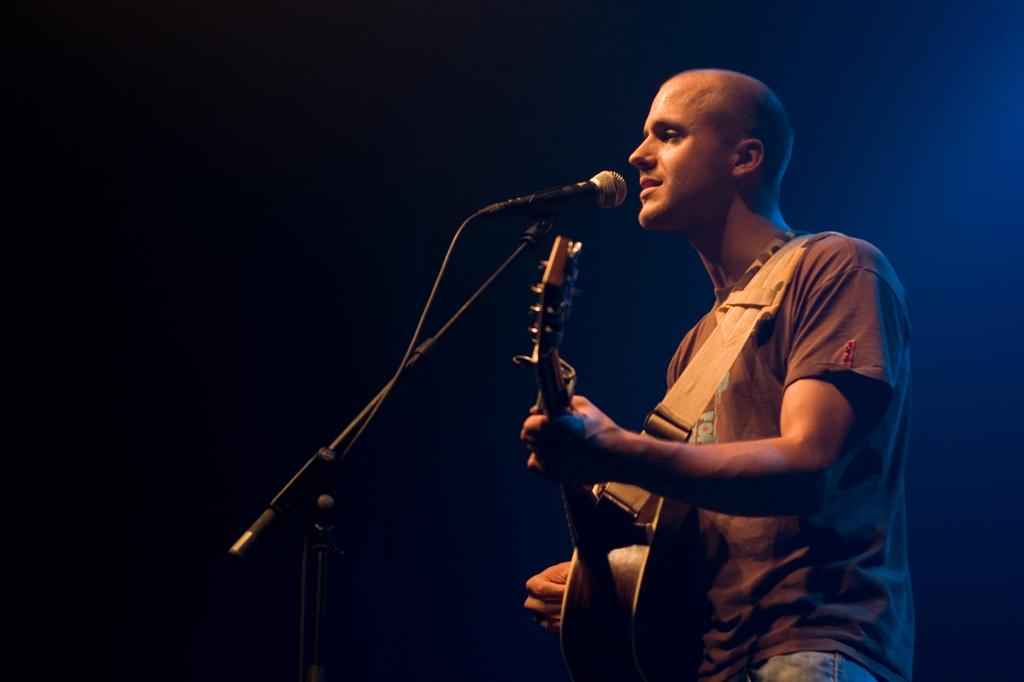What is the man in the image doing? The man is singing on a mic. What instrument is the man holding in the image? The man is holding a guitar. What type of headphones is the man wearing in the image? There is no mention of headphones in the image, so it cannot be determined if the man is wearing any. 